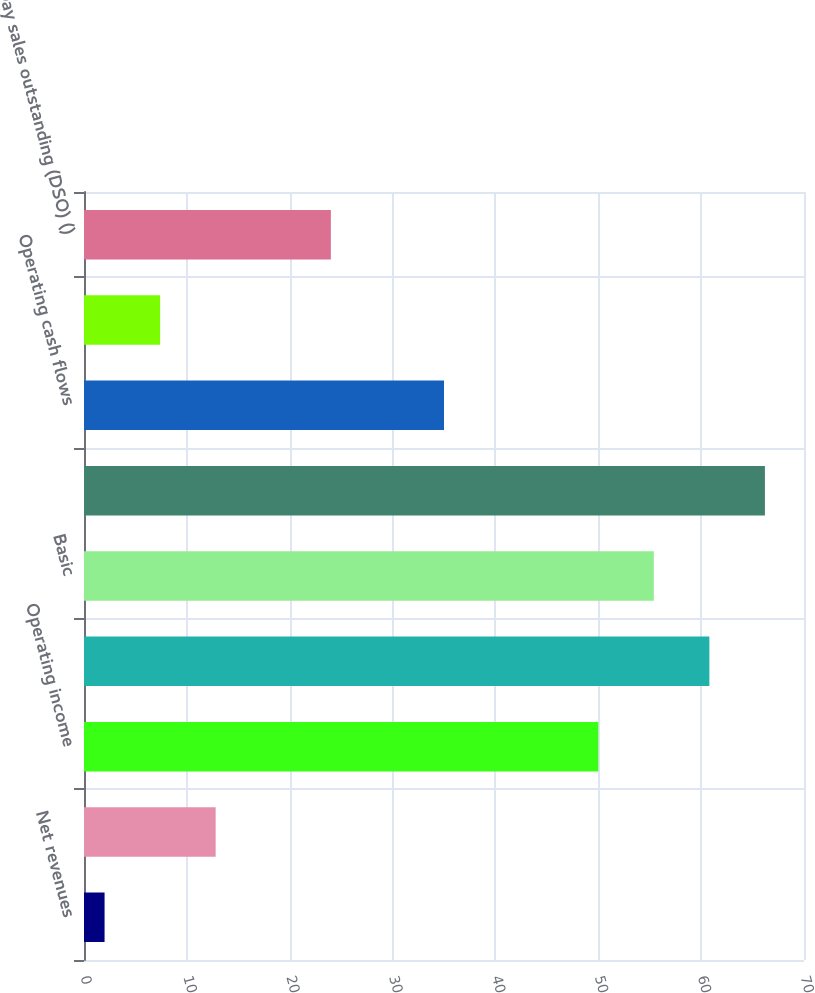Convert chart. <chart><loc_0><loc_0><loc_500><loc_500><bar_chart><fcel>Net revenues<fcel>Gross Margin<fcel>Operating income<fcel>Net income attributable to<fcel>Basic<fcel>Diluted<fcel>Operating cash flows<fcel>Deferred revenue<fcel>Day sales outstanding (DSO) ()<nl><fcel>2<fcel>12.8<fcel>50<fcel>60.8<fcel>55.4<fcel>66.2<fcel>35<fcel>7.4<fcel>24<nl></chart> 